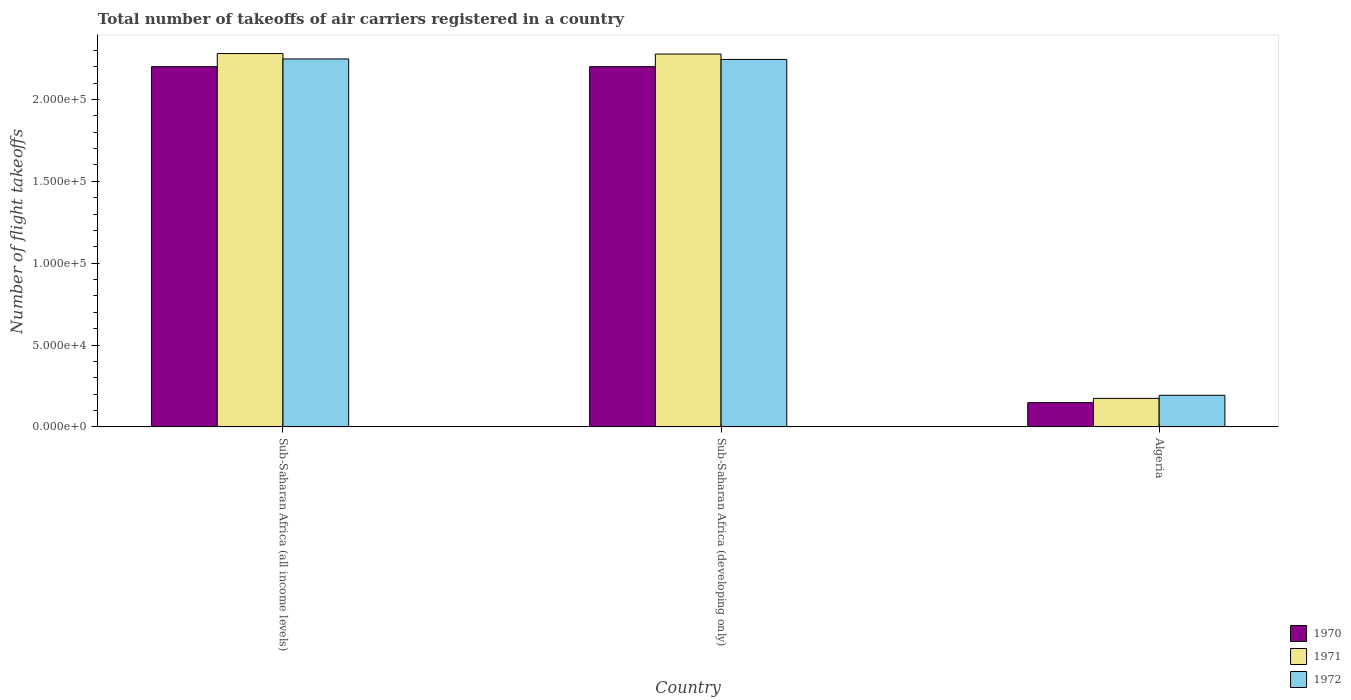How many different coloured bars are there?
Offer a terse response. 3. Are the number of bars per tick equal to the number of legend labels?
Give a very brief answer. Yes. How many bars are there on the 3rd tick from the left?
Provide a succinct answer. 3. What is the label of the 1st group of bars from the left?
Offer a terse response. Sub-Saharan Africa (all income levels). In how many cases, is the number of bars for a given country not equal to the number of legend labels?
Provide a succinct answer. 0. What is the total number of flight takeoffs in 1972 in Sub-Saharan Africa (all income levels)?
Offer a terse response. 2.25e+05. Across all countries, what is the maximum total number of flight takeoffs in 1970?
Provide a succinct answer. 2.20e+05. Across all countries, what is the minimum total number of flight takeoffs in 1972?
Your response must be concise. 1.93e+04. In which country was the total number of flight takeoffs in 1971 maximum?
Ensure brevity in your answer.  Sub-Saharan Africa (all income levels). In which country was the total number of flight takeoffs in 1971 minimum?
Give a very brief answer. Algeria. What is the total total number of flight takeoffs in 1971 in the graph?
Give a very brief answer. 4.73e+05. What is the difference between the total number of flight takeoffs in 1971 in Algeria and that in Sub-Saharan Africa (developing only)?
Make the answer very short. -2.10e+05. What is the difference between the total number of flight takeoffs in 1972 in Algeria and the total number of flight takeoffs in 1970 in Sub-Saharan Africa (developing only)?
Make the answer very short. -2.01e+05. What is the average total number of flight takeoffs in 1972 per country?
Give a very brief answer. 1.56e+05. What is the difference between the total number of flight takeoffs of/in 1970 and total number of flight takeoffs of/in 1971 in Sub-Saharan Africa (developing only)?
Provide a short and direct response. -7700. In how many countries, is the total number of flight takeoffs in 1970 greater than 80000?
Provide a succinct answer. 2. What is the ratio of the total number of flight takeoffs in 1971 in Sub-Saharan Africa (all income levels) to that in Sub-Saharan Africa (developing only)?
Offer a very short reply. 1. Is the total number of flight takeoffs in 1971 in Sub-Saharan Africa (all income levels) less than that in Sub-Saharan Africa (developing only)?
Your answer should be compact. No. Is the difference between the total number of flight takeoffs in 1970 in Algeria and Sub-Saharan Africa (developing only) greater than the difference between the total number of flight takeoffs in 1971 in Algeria and Sub-Saharan Africa (developing only)?
Offer a terse response. Yes. What is the difference between the highest and the second highest total number of flight takeoffs in 1970?
Offer a very short reply. 2.05e+05. What is the difference between the highest and the lowest total number of flight takeoffs in 1972?
Ensure brevity in your answer.  2.05e+05. Is the sum of the total number of flight takeoffs in 1971 in Sub-Saharan Africa (all income levels) and Sub-Saharan Africa (developing only) greater than the maximum total number of flight takeoffs in 1970 across all countries?
Make the answer very short. Yes. What does the 1st bar from the right in Sub-Saharan Africa (developing only) represents?
Keep it short and to the point. 1972. Is it the case that in every country, the sum of the total number of flight takeoffs in 1971 and total number of flight takeoffs in 1970 is greater than the total number of flight takeoffs in 1972?
Your answer should be very brief. Yes. How many bars are there?
Offer a terse response. 9. How many countries are there in the graph?
Ensure brevity in your answer.  3. What is the difference between two consecutive major ticks on the Y-axis?
Provide a succinct answer. 5.00e+04. Are the values on the major ticks of Y-axis written in scientific E-notation?
Offer a very short reply. Yes. Does the graph contain any zero values?
Make the answer very short. No. Does the graph contain grids?
Ensure brevity in your answer.  No. What is the title of the graph?
Offer a very short reply. Total number of takeoffs of air carriers registered in a country. Does "2013" appear as one of the legend labels in the graph?
Provide a succinct answer. No. What is the label or title of the X-axis?
Offer a very short reply. Country. What is the label or title of the Y-axis?
Give a very brief answer. Number of flight takeoffs. What is the Number of flight takeoffs in 1971 in Sub-Saharan Africa (all income levels)?
Provide a succinct answer. 2.28e+05. What is the Number of flight takeoffs in 1972 in Sub-Saharan Africa (all income levels)?
Your response must be concise. 2.25e+05. What is the Number of flight takeoffs of 1970 in Sub-Saharan Africa (developing only)?
Your answer should be compact. 2.20e+05. What is the Number of flight takeoffs in 1971 in Sub-Saharan Africa (developing only)?
Keep it short and to the point. 2.28e+05. What is the Number of flight takeoffs in 1972 in Sub-Saharan Africa (developing only)?
Provide a succinct answer. 2.24e+05. What is the Number of flight takeoffs in 1970 in Algeria?
Make the answer very short. 1.48e+04. What is the Number of flight takeoffs in 1971 in Algeria?
Offer a very short reply. 1.74e+04. What is the Number of flight takeoffs of 1972 in Algeria?
Your answer should be compact. 1.93e+04. Across all countries, what is the maximum Number of flight takeoffs of 1971?
Your answer should be very brief. 2.28e+05. Across all countries, what is the maximum Number of flight takeoffs in 1972?
Your answer should be very brief. 2.25e+05. Across all countries, what is the minimum Number of flight takeoffs in 1970?
Your answer should be compact. 1.48e+04. Across all countries, what is the minimum Number of flight takeoffs in 1971?
Provide a succinct answer. 1.74e+04. Across all countries, what is the minimum Number of flight takeoffs of 1972?
Provide a short and direct response. 1.93e+04. What is the total Number of flight takeoffs of 1970 in the graph?
Give a very brief answer. 4.55e+05. What is the total Number of flight takeoffs of 1971 in the graph?
Offer a terse response. 4.73e+05. What is the total Number of flight takeoffs in 1972 in the graph?
Give a very brief answer. 4.68e+05. What is the difference between the Number of flight takeoffs of 1971 in Sub-Saharan Africa (all income levels) and that in Sub-Saharan Africa (developing only)?
Offer a very short reply. 300. What is the difference between the Number of flight takeoffs in 1972 in Sub-Saharan Africa (all income levels) and that in Sub-Saharan Africa (developing only)?
Offer a very short reply. 300. What is the difference between the Number of flight takeoffs in 1970 in Sub-Saharan Africa (all income levels) and that in Algeria?
Your answer should be very brief. 2.05e+05. What is the difference between the Number of flight takeoffs of 1971 in Sub-Saharan Africa (all income levels) and that in Algeria?
Your response must be concise. 2.11e+05. What is the difference between the Number of flight takeoffs in 1972 in Sub-Saharan Africa (all income levels) and that in Algeria?
Provide a succinct answer. 2.05e+05. What is the difference between the Number of flight takeoffs of 1970 in Sub-Saharan Africa (developing only) and that in Algeria?
Ensure brevity in your answer.  2.05e+05. What is the difference between the Number of flight takeoffs of 1971 in Sub-Saharan Africa (developing only) and that in Algeria?
Provide a short and direct response. 2.10e+05. What is the difference between the Number of flight takeoffs in 1972 in Sub-Saharan Africa (developing only) and that in Algeria?
Provide a short and direct response. 2.05e+05. What is the difference between the Number of flight takeoffs in 1970 in Sub-Saharan Africa (all income levels) and the Number of flight takeoffs in 1971 in Sub-Saharan Africa (developing only)?
Offer a very short reply. -7700. What is the difference between the Number of flight takeoffs in 1970 in Sub-Saharan Africa (all income levels) and the Number of flight takeoffs in 1972 in Sub-Saharan Africa (developing only)?
Make the answer very short. -4400. What is the difference between the Number of flight takeoffs of 1971 in Sub-Saharan Africa (all income levels) and the Number of flight takeoffs of 1972 in Sub-Saharan Africa (developing only)?
Provide a succinct answer. 3600. What is the difference between the Number of flight takeoffs in 1970 in Sub-Saharan Africa (all income levels) and the Number of flight takeoffs in 1971 in Algeria?
Provide a short and direct response. 2.03e+05. What is the difference between the Number of flight takeoffs of 1970 in Sub-Saharan Africa (all income levels) and the Number of flight takeoffs of 1972 in Algeria?
Your answer should be very brief. 2.01e+05. What is the difference between the Number of flight takeoffs of 1971 in Sub-Saharan Africa (all income levels) and the Number of flight takeoffs of 1972 in Algeria?
Your answer should be very brief. 2.09e+05. What is the difference between the Number of flight takeoffs of 1970 in Sub-Saharan Africa (developing only) and the Number of flight takeoffs of 1971 in Algeria?
Offer a very short reply. 2.03e+05. What is the difference between the Number of flight takeoffs in 1970 in Sub-Saharan Africa (developing only) and the Number of flight takeoffs in 1972 in Algeria?
Offer a very short reply. 2.01e+05. What is the difference between the Number of flight takeoffs in 1971 in Sub-Saharan Africa (developing only) and the Number of flight takeoffs in 1972 in Algeria?
Provide a short and direct response. 2.08e+05. What is the average Number of flight takeoffs in 1970 per country?
Offer a terse response. 1.52e+05. What is the average Number of flight takeoffs in 1971 per country?
Your answer should be very brief. 1.58e+05. What is the average Number of flight takeoffs of 1972 per country?
Provide a short and direct response. 1.56e+05. What is the difference between the Number of flight takeoffs of 1970 and Number of flight takeoffs of 1971 in Sub-Saharan Africa (all income levels)?
Offer a terse response. -8000. What is the difference between the Number of flight takeoffs in 1970 and Number of flight takeoffs in 1972 in Sub-Saharan Africa (all income levels)?
Your answer should be compact. -4700. What is the difference between the Number of flight takeoffs in 1971 and Number of flight takeoffs in 1972 in Sub-Saharan Africa (all income levels)?
Offer a very short reply. 3300. What is the difference between the Number of flight takeoffs of 1970 and Number of flight takeoffs of 1971 in Sub-Saharan Africa (developing only)?
Provide a short and direct response. -7700. What is the difference between the Number of flight takeoffs in 1970 and Number of flight takeoffs in 1972 in Sub-Saharan Africa (developing only)?
Keep it short and to the point. -4400. What is the difference between the Number of flight takeoffs in 1971 and Number of flight takeoffs in 1972 in Sub-Saharan Africa (developing only)?
Give a very brief answer. 3300. What is the difference between the Number of flight takeoffs in 1970 and Number of flight takeoffs in 1971 in Algeria?
Your response must be concise. -2600. What is the difference between the Number of flight takeoffs in 1970 and Number of flight takeoffs in 1972 in Algeria?
Give a very brief answer. -4500. What is the difference between the Number of flight takeoffs of 1971 and Number of flight takeoffs of 1972 in Algeria?
Ensure brevity in your answer.  -1900. What is the ratio of the Number of flight takeoffs of 1971 in Sub-Saharan Africa (all income levels) to that in Sub-Saharan Africa (developing only)?
Keep it short and to the point. 1. What is the ratio of the Number of flight takeoffs in 1970 in Sub-Saharan Africa (all income levels) to that in Algeria?
Provide a succinct answer. 14.86. What is the ratio of the Number of flight takeoffs in 1971 in Sub-Saharan Africa (all income levels) to that in Algeria?
Your response must be concise. 13.1. What is the ratio of the Number of flight takeoffs of 1972 in Sub-Saharan Africa (all income levels) to that in Algeria?
Your response must be concise. 11.64. What is the ratio of the Number of flight takeoffs of 1970 in Sub-Saharan Africa (developing only) to that in Algeria?
Offer a terse response. 14.86. What is the ratio of the Number of flight takeoffs in 1971 in Sub-Saharan Africa (developing only) to that in Algeria?
Offer a very short reply. 13.09. What is the ratio of the Number of flight takeoffs of 1972 in Sub-Saharan Africa (developing only) to that in Algeria?
Keep it short and to the point. 11.63. What is the difference between the highest and the second highest Number of flight takeoffs of 1970?
Ensure brevity in your answer.  0. What is the difference between the highest and the second highest Number of flight takeoffs in 1971?
Ensure brevity in your answer.  300. What is the difference between the highest and the second highest Number of flight takeoffs of 1972?
Keep it short and to the point. 300. What is the difference between the highest and the lowest Number of flight takeoffs in 1970?
Offer a very short reply. 2.05e+05. What is the difference between the highest and the lowest Number of flight takeoffs of 1971?
Offer a terse response. 2.11e+05. What is the difference between the highest and the lowest Number of flight takeoffs of 1972?
Offer a very short reply. 2.05e+05. 